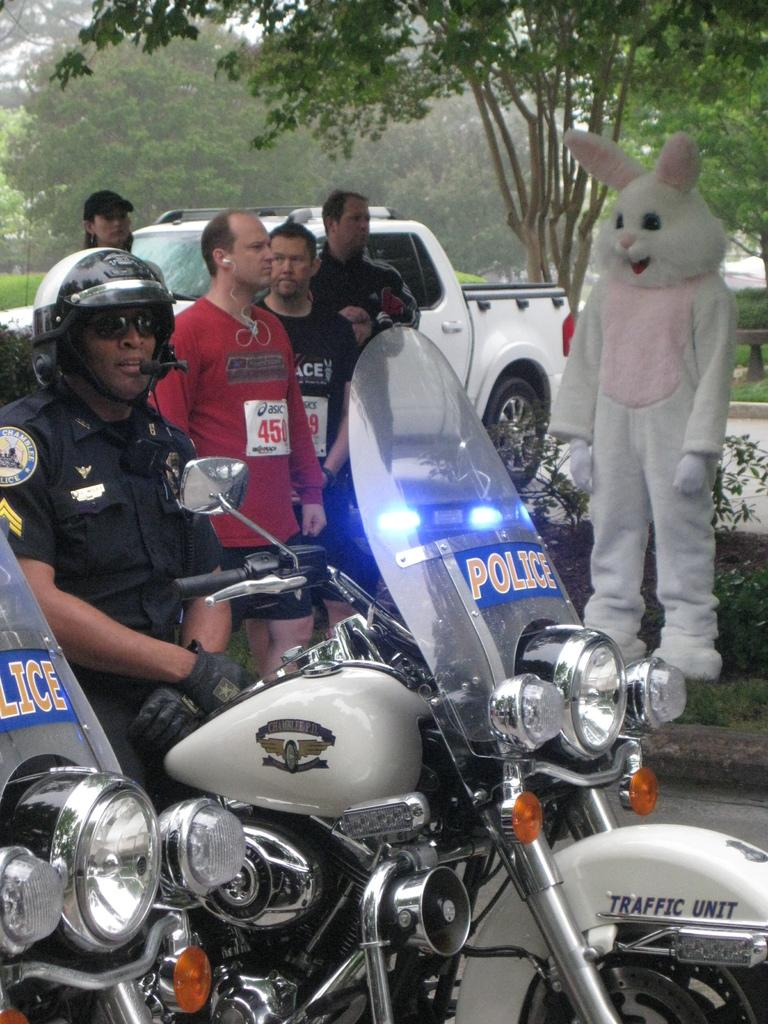What is the police officer doing in the image? The police officer is sitting on a bike. What can be seen beside the police officer's bike? There is another bike beside the police officer's bike. Who else is present in the image besides the police officer? There is a group of people in the image. What type of vehicle is visible in the image? There is a car in the image. What type of natural elements can be seen in the image? There are trees in the image. How deep is the hole in the image? There is no hole present in the image. 